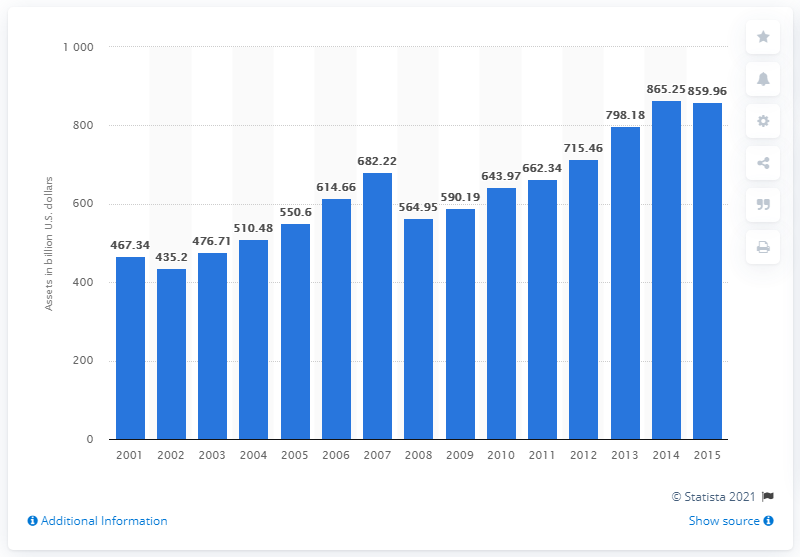Outline some significant characteristics in this image. The total assets of foundations in the United States in 2015 were approximately $859.96 billion. 